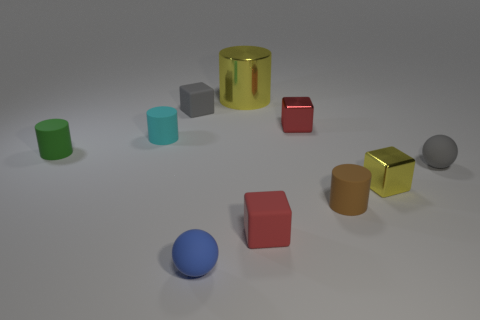Which objects stand out due to their unique color compared to others? The red cube and the blue sphere immediately catch the eye as unique colors in the assortment, setting themselves apart from the multiple objects sharing green, gray, and golden tones. 